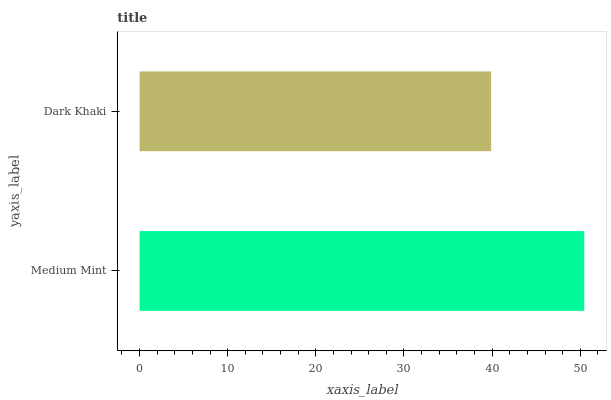Is Dark Khaki the minimum?
Answer yes or no. Yes. Is Medium Mint the maximum?
Answer yes or no. Yes. Is Dark Khaki the maximum?
Answer yes or no. No. Is Medium Mint greater than Dark Khaki?
Answer yes or no. Yes. Is Dark Khaki less than Medium Mint?
Answer yes or no. Yes. Is Dark Khaki greater than Medium Mint?
Answer yes or no. No. Is Medium Mint less than Dark Khaki?
Answer yes or no. No. Is Medium Mint the high median?
Answer yes or no. Yes. Is Dark Khaki the low median?
Answer yes or no. Yes. Is Dark Khaki the high median?
Answer yes or no. No. Is Medium Mint the low median?
Answer yes or no. No. 